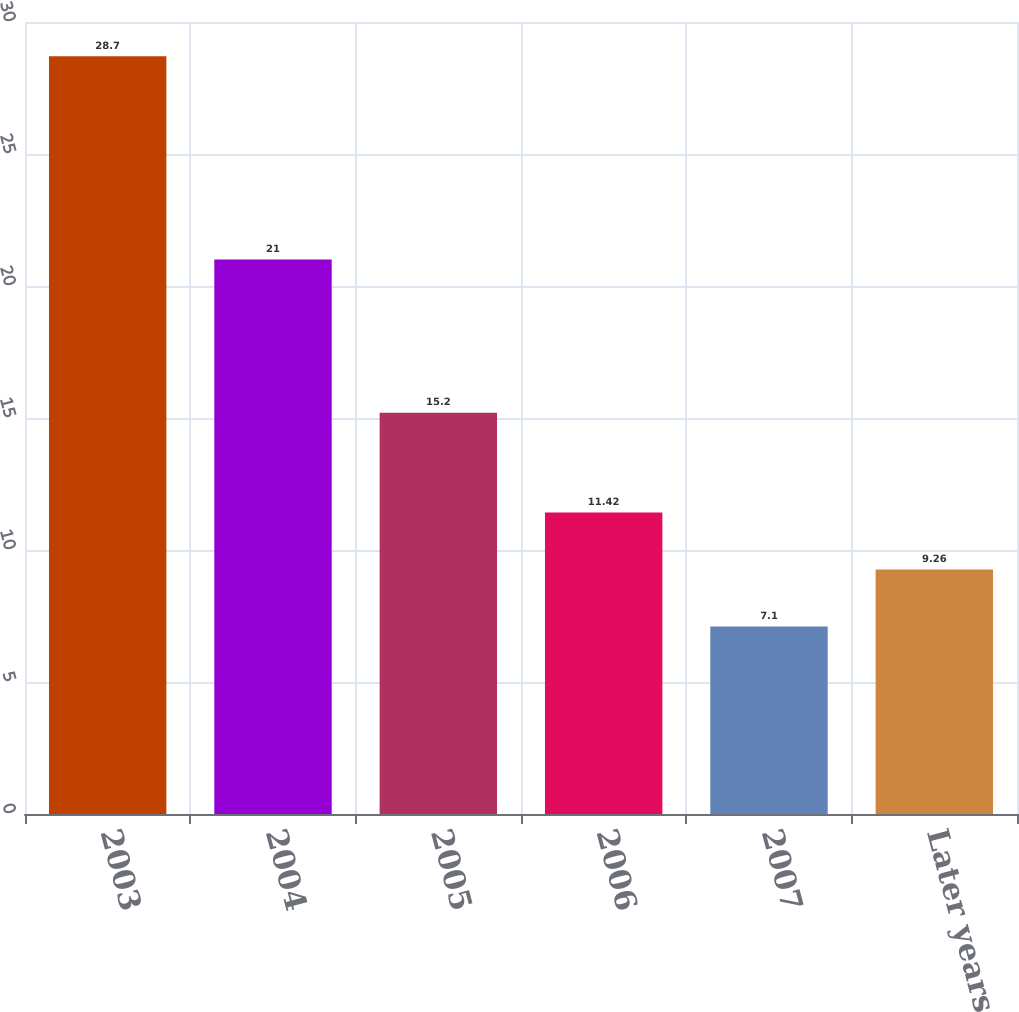Convert chart. <chart><loc_0><loc_0><loc_500><loc_500><bar_chart><fcel>2003<fcel>2004<fcel>2005<fcel>2006<fcel>2007<fcel>Later years<nl><fcel>28.7<fcel>21<fcel>15.2<fcel>11.42<fcel>7.1<fcel>9.26<nl></chart> 